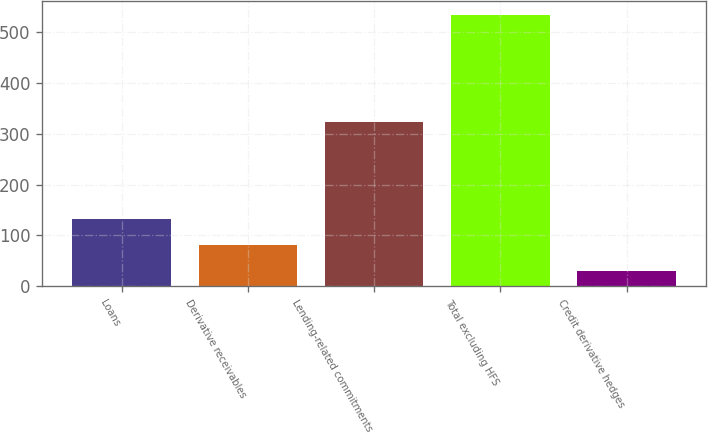Convert chart. <chart><loc_0><loc_0><loc_500><loc_500><bar_chart><fcel>Loans<fcel>Derivative receivables<fcel>Lending-related commitments<fcel>Total excluding HFS<fcel>Credit derivative hedges<nl><fcel>132<fcel>80.5<fcel>324<fcel>535<fcel>30<nl></chart> 